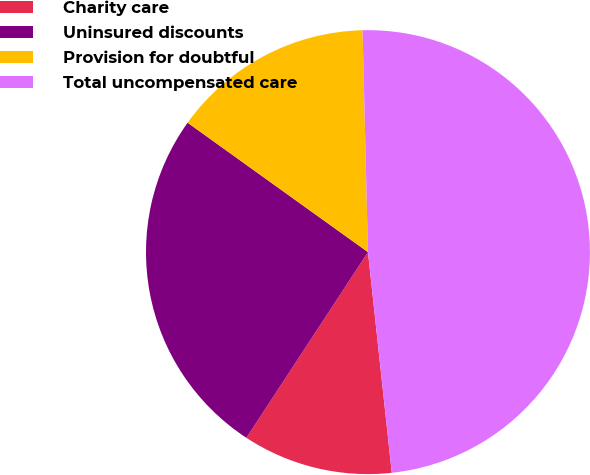<chart> <loc_0><loc_0><loc_500><loc_500><pie_chart><fcel>Charity care<fcel>Uninsured discounts<fcel>Provision for doubtful<fcel>Total uncompensated care<nl><fcel>10.94%<fcel>25.68%<fcel>14.71%<fcel>48.68%<nl></chart> 